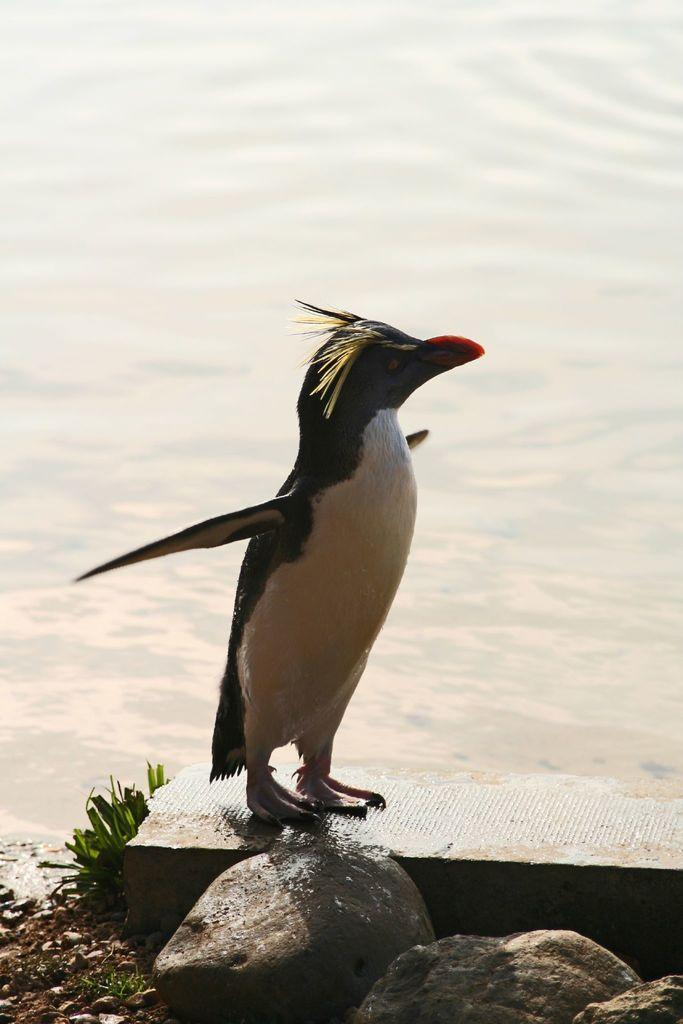What type of animal is standing in the image? There is a penguin standing in the image. What type of terrain is visible in the image? There are rocks and grass visible in the image. What is the ground made of in the image? The ground is visible in the image. What type of natural feature is present in the image? There is water visible in the image. What type of metal is being used to construct the government building in the image? There is no government building present in the image, and therefore no metal can be identified. 